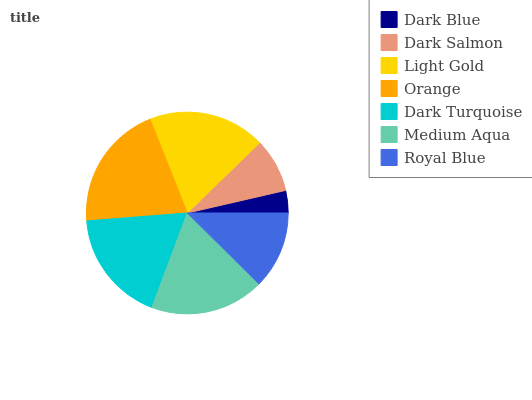Is Dark Blue the minimum?
Answer yes or no. Yes. Is Orange the maximum?
Answer yes or no. Yes. Is Dark Salmon the minimum?
Answer yes or no. No. Is Dark Salmon the maximum?
Answer yes or no. No. Is Dark Salmon greater than Dark Blue?
Answer yes or no. Yes. Is Dark Blue less than Dark Salmon?
Answer yes or no. Yes. Is Dark Blue greater than Dark Salmon?
Answer yes or no. No. Is Dark Salmon less than Dark Blue?
Answer yes or no. No. Is Dark Turquoise the high median?
Answer yes or no. Yes. Is Dark Turquoise the low median?
Answer yes or no. Yes. Is Royal Blue the high median?
Answer yes or no. No. Is Dark Blue the low median?
Answer yes or no. No. 